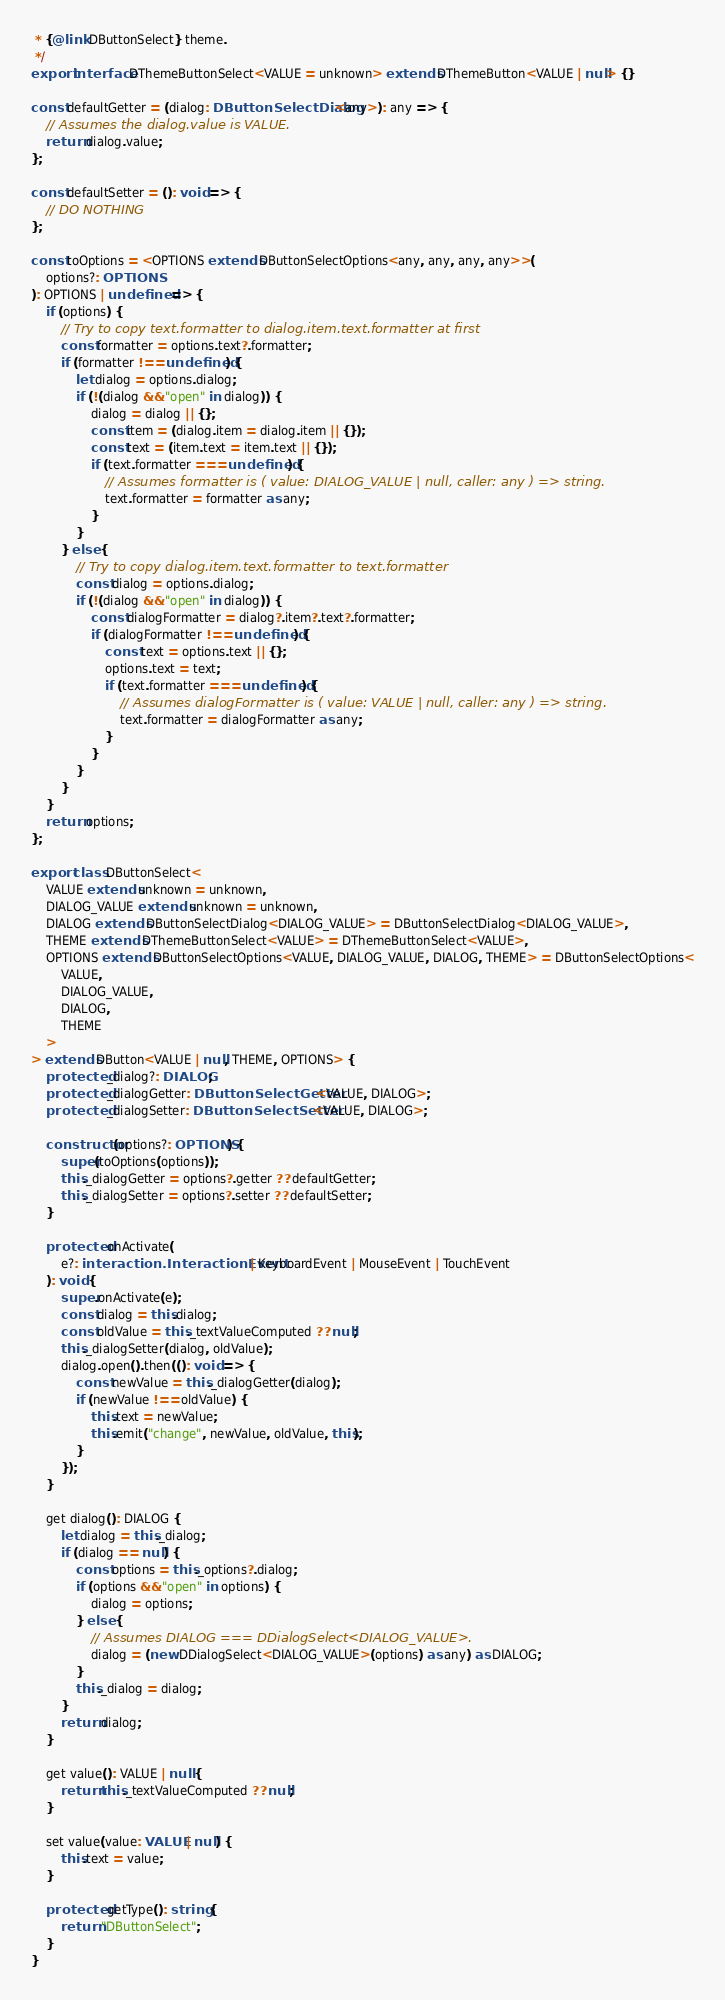Convert code to text. <code><loc_0><loc_0><loc_500><loc_500><_TypeScript_> * {@link DButtonSelect} theme.
 */
export interface DThemeButtonSelect<VALUE = unknown> extends DThemeButton<VALUE | null> {}

const defaultGetter = (dialog: DButtonSelectDialog<any>): any => {
	// Assumes the dialog.value is VALUE.
	return dialog.value;
};

const defaultSetter = (): void => {
	// DO NOTHING
};

const toOptions = <OPTIONS extends DButtonSelectOptions<any, any, any, any>>(
	options?: OPTIONS
): OPTIONS | undefined => {
	if (options) {
		// Try to copy text.formatter to dialog.item.text.formatter at first
		const formatter = options.text?.formatter;
		if (formatter !== undefined) {
			let dialog = options.dialog;
			if (!(dialog && "open" in dialog)) {
				dialog = dialog || {};
				const item = (dialog.item = dialog.item || {});
				const text = (item.text = item.text || {});
				if (text.formatter === undefined) {
					// Assumes formatter is ( value: DIALOG_VALUE | null, caller: any ) => string.
					text.formatter = formatter as any;
				}
			}
		} else {
			// Try to copy dialog.item.text.formatter to text.formatter
			const dialog = options.dialog;
			if (!(dialog && "open" in dialog)) {
				const dialogFormatter = dialog?.item?.text?.formatter;
				if (dialogFormatter !== undefined) {
					const text = options.text || {};
					options.text = text;
					if (text.formatter === undefined) {
						// Assumes dialogFormatter is ( value: VALUE | null, caller: any ) => string.
						text.formatter = dialogFormatter as any;
					}
				}
			}
		}
	}
	return options;
};

export class DButtonSelect<
	VALUE extends unknown = unknown,
	DIALOG_VALUE extends unknown = unknown,
	DIALOG extends DButtonSelectDialog<DIALOG_VALUE> = DButtonSelectDialog<DIALOG_VALUE>,
	THEME extends DThemeButtonSelect<VALUE> = DThemeButtonSelect<VALUE>,
	OPTIONS extends DButtonSelectOptions<VALUE, DIALOG_VALUE, DIALOG, THEME> = DButtonSelectOptions<
		VALUE,
		DIALOG_VALUE,
		DIALOG,
		THEME
	>
> extends DButton<VALUE | null, THEME, OPTIONS> {
	protected _dialog?: DIALOG;
	protected _dialogGetter: DButtonSelectGetter<VALUE, DIALOG>;
	protected _dialogSetter: DButtonSelectSetter<VALUE, DIALOG>;

	constructor(options?: OPTIONS) {
		super(toOptions(options));
		this._dialogGetter = options?.getter ?? defaultGetter;
		this._dialogSetter = options?.setter ?? defaultSetter;
	}

	protected onActivate(
		e?: interaction.InteractionEvent | KeyboardEvent | MouseEvent | TouchEvent
	): void {
		super.onActivate(e);
		const dialog = this.dialog;
		const oldValue = this._textValueComputed ?? null;
		this._dialogSetter(dialog, oldValue);
		dialog.open().then((): void => {
			const newValue = this._dialogGetter(dialog);
			if (newValue !== oldValue) {
				this.text = newValue;
				this.emit("change", newValue, oldValue, this);
			}
		});
	}

	get dialog(): DIALOG {
		let dialog = this._dialog;
		if (dialog == null) {
			const options = this._options?.dialog;
			if (options && "open" in options) {
				dialog = options;
			} else {
				// Assumes DIALOG === DDialogSelect<DIALOG_VALUE>.
				dialog = (new DDialogSelect<DIALOG_VALUE>(options) as any) as DIALOG;
			}
			this._dialog = dialog;
		}
		return dialog;
	}

	get value(): VALUE | null {
		return this._textValueComputed ?? null;
	}

	set value(value: VALUE | null) {
		this.text = value;
	}

	protected getType(): string {
		return "DButtonSelect";
	}
}
</code> 